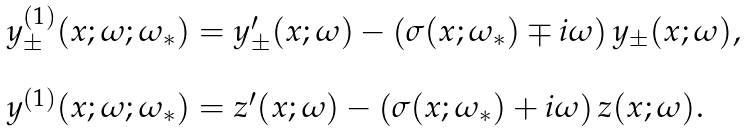Convert formula to latex. <formula><loc_0><loc_0><loc_500><loc_500>\begin{array} { l } y ^ { ( 1 ) } _ { \pm } ( x ; \omega ; \omega _ { * } ) = y ^ { \prime } _ { \pm } ( x ; \omega ) - \left ( \sigma ( x ; \omega _ { * } ) \mp i \omega \right ) y _ { \pm } ( x ; \omega ) , \\ \\ y ^ { ( 1 ) } ( x ; \omega ; \omega _ { * } ) = z ^ { \prime } ( x ; \omega ) - \left ( \sigma ( x ; \omega _ { * } ) + i \omega \right ) z ( x ; \omega ) . \end{array}</formula> 